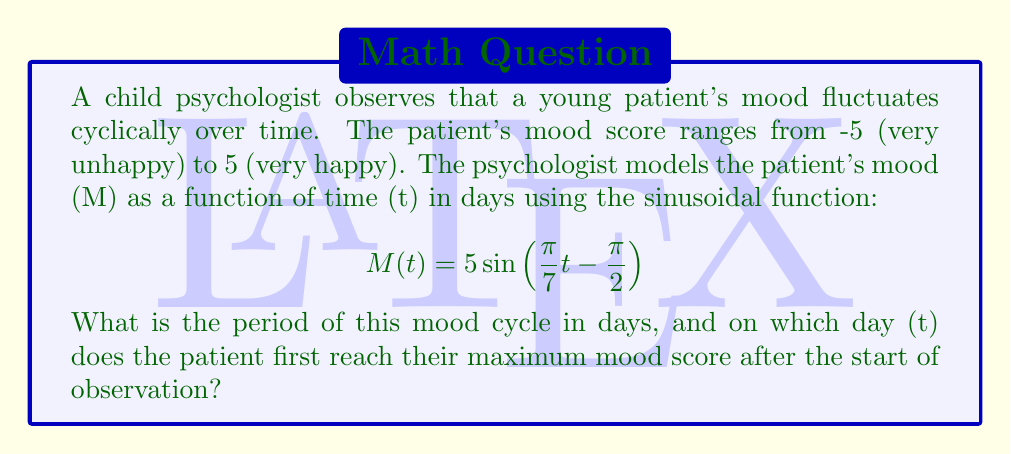Could you help me with this problem? 1. To find the period of the mood cycle, we need to identify the coefficient of t inside the sine function. The general form of a sinusoidal function is:

   $$ f(t) = A\sin(Bt + C) + D $$

   where $B = \frac{2\pi}{P}$, and P is the period.

2. In our function, $B = \frac{\pi}{7}$. So:

   $$ \frac{\pi}{7} = \frac{2\pi}{P} $$

3. Solving for P:
   $$ P = \frac{2\pi}{\frac{\pi}{7}} = 2\pi \cdot \frac{7}{\pi} = 14 $$

4. To find when the patient first reaches their maximum mood score, we need to solve:

   $$ 5\sin\left(\frac{\pi}{7}t - \frac{\pi}{2}\right) = 5 $$

5. This occurs when the sine function equals 1, which happens when its argument is $\frac{\pi}{2}$:

   $$ \frac{\pi}{7}t - \frac{\pi}{2} = \frac{\pi}{2} $$

6. Solving for t:
   $$ \frac{\pi}{7}t = \pi $$
   $$ t = 7 $$

Therefore, the period of the mood cycle is 14 days, and the patient first reaches their maximum mood score 7 days after the start of observation.
Answer: Period: 14 days; Maximum mood: Day 7 